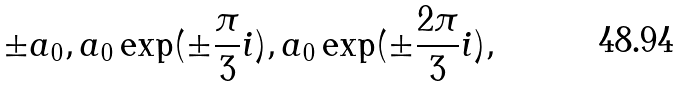Convert formula to latex. <formula><loc_0><loc_0><loc_500><loc_500>\pm { a _ { 0 } } , a _ { 0 } \exp ( \pm \frac { \pi } { 3 } i ) , a _ { 0 } \exp ( \pm \frac { 2 \pi } { 3 } i ) ,</formula> 